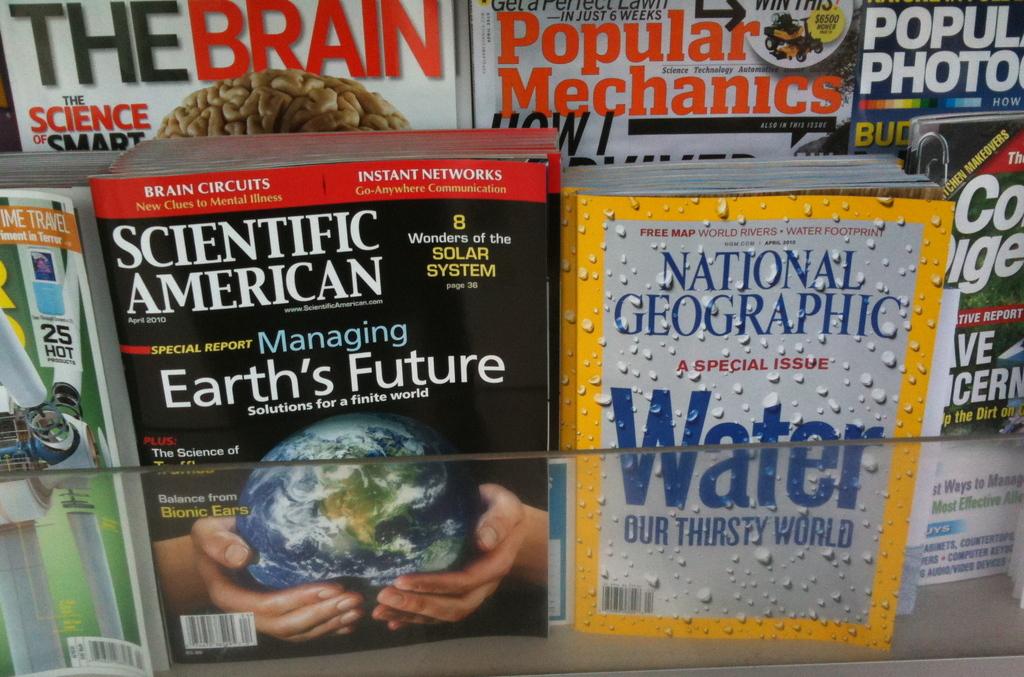What genre of book collection is this?
Make the answer very short. Science. 